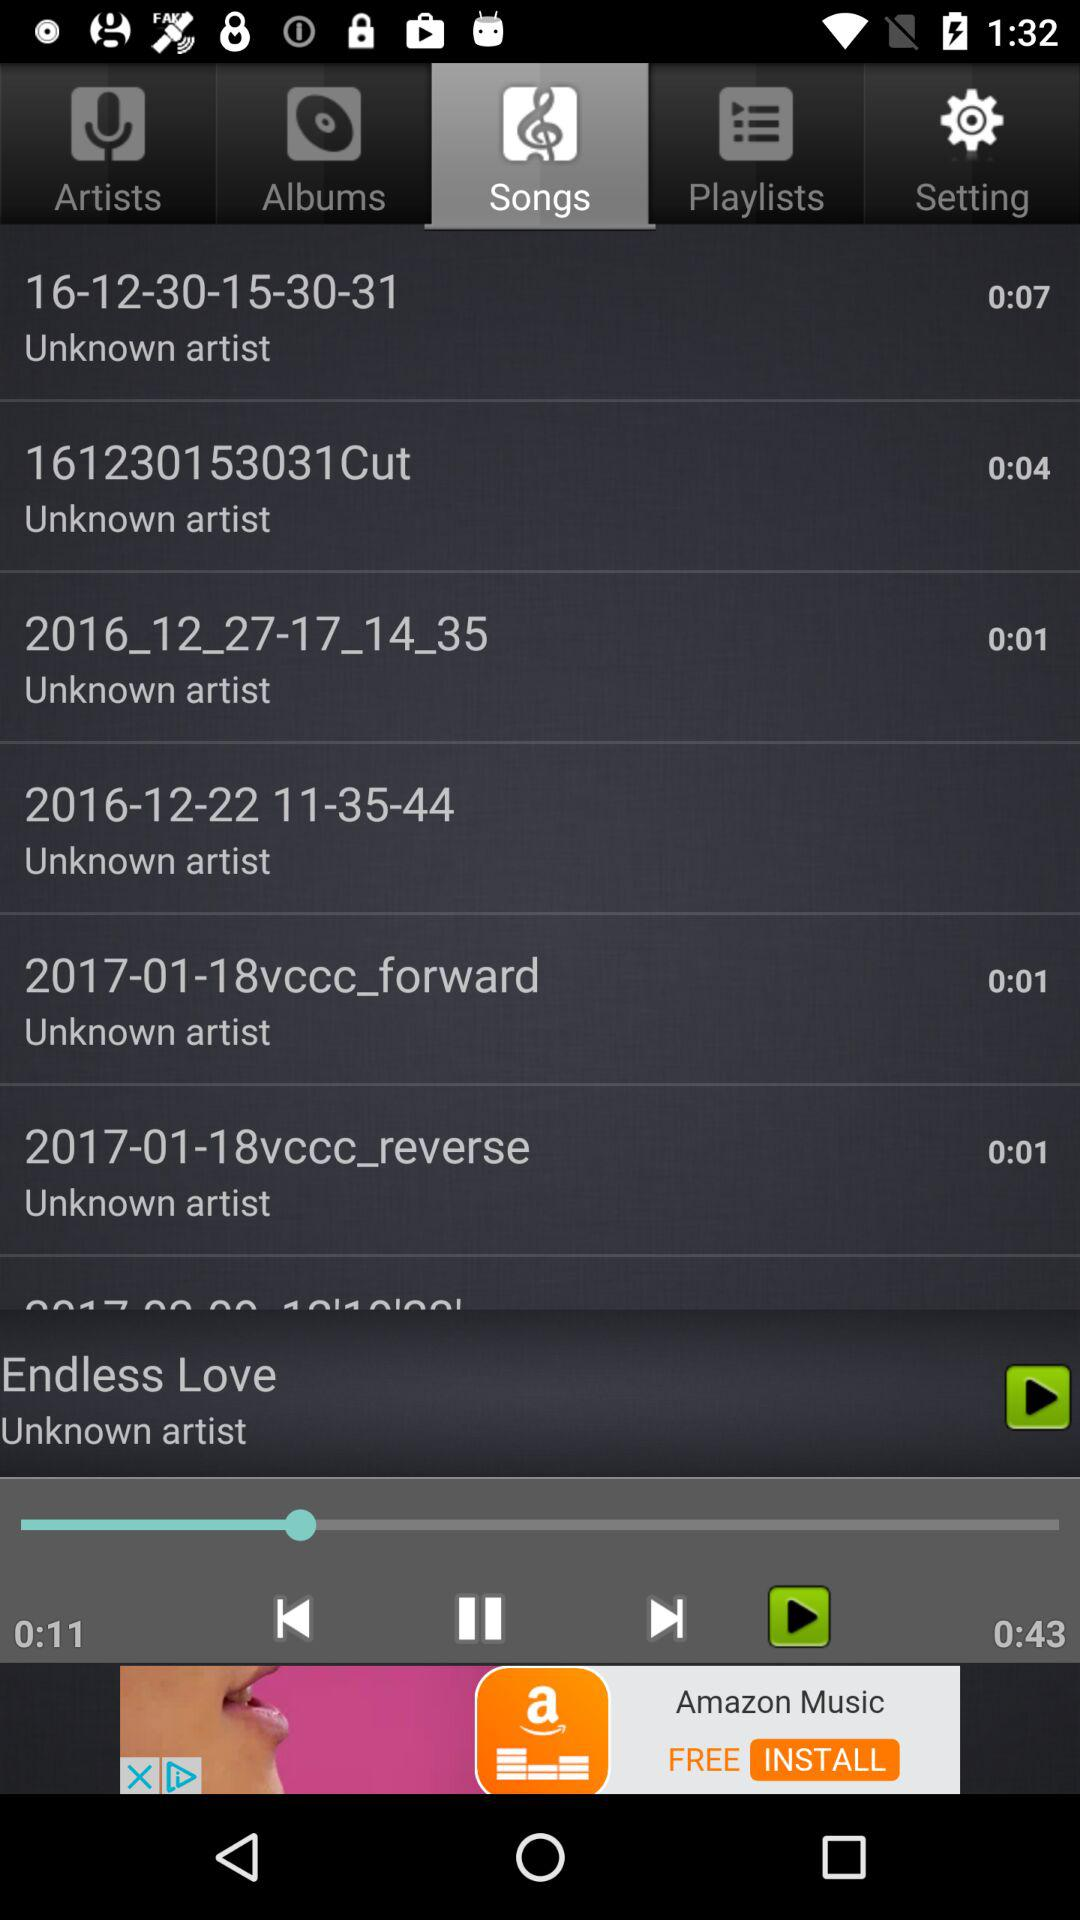How many seconds is the longest song?
Answer the question using a single word or phrase. 0:43 